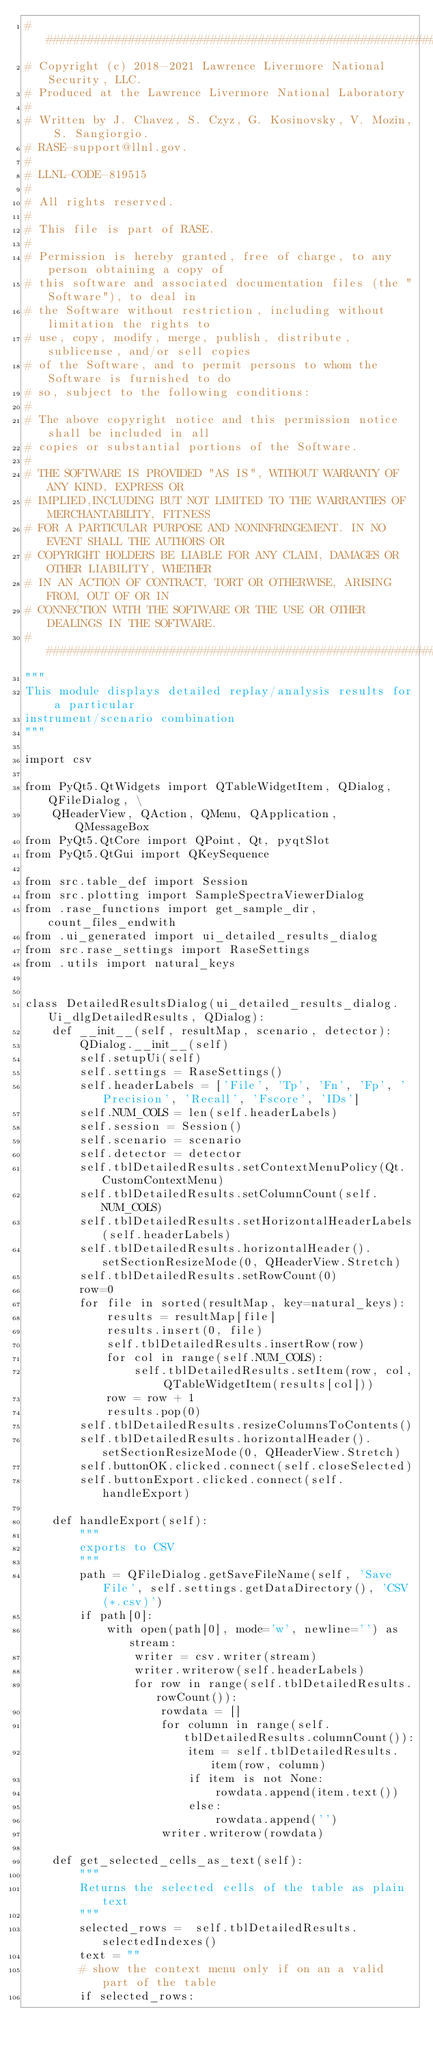Convert code to text. <code><loc_0><loc_0><loc_500><loc_500><_Python_>###############################################################################
# Copyright (c) 2018-2021 Lawrence Livermore National Security, LLC.
# Produced at the Lawrence Livermore National Laboratory
#
# Written by J. Chavez, S. Czyz, G. Kosinovsky, V. Mozin, S. Sangiorgio.
# RASE-support@llnl.gov.
#
# LLNL-CODE-819515
#
# All rights reserved.
#
# This file is part of RASE.
#
# Permission is hereby granted, free of charge, to any person obtaining a copy of
# this software and associated documentation files (the "Software"), to deal in
# the Software without restriction, including without limitation the rights to
# use, copy, modify, merge, publish, distribute, sublicense, and/or sell copies
# of the Software, and to permit persons to whom the Software is furnished to do
# so, subject to the following conditions:
#
# The above copyright notice and this permission notice shall be included in all
# copies or substantial portions of the Software.
#
# THE SOFTWARE IS PROVIDED "AS IS", WITHOUT WARRANTY OF ANY KIND, EXPRESS OR
# IMPLIED,INCLUDING BUT NOT LIMITED TO THE WARRANTIES OF MERCHANTABILITY, FITNESS
# FOR A PARTICULAR PURPOSE AND NONINFRINGEMENT. IN NO EVENT SHALL THE AUTHORS OR
# COPYRIGHT HOLDERS BE LIABLE FOR ANY CLAIM, DAMAGES OR OTHER LIABILITY, WHETHER
# IN AN ACTION OF CONTRACT, TORT OR OTHERWISE, ARISING FROM, OUT OF OR IN
# CONNECTION WITH THE SOFTWARE OR THE USE OR OTHER DEALINGS IN THE SOFTWARE.
###############################################################################
"""
This module displays detailed replay/analysis results for a particular
instrument/scenario combination
"""

import csv

from PyQt5.QtWidgets import QTableWidgetItem, QDialog, QFileDialog, \
    QHeaderView, QAction, QMenu, QApplication, QMessageBox
from PyQt5.QtCore import QPoint, Qt, pyqtSlot
from PyQt5.QtGui import QKeySequence

from src.table_def import Session
from src.plotting import SampleSpectraViewerDialog
from .rase_functions import get_sample_dir, count_files_endwith
from .ui_generated import ui_detailed_results_dialog
from src.rase_settings import RaseSettings
from .utils import natural_keys


class DetailedResultsDialog(ui_detailed_results_dialog.Ui_dlgDetailedResults, QDialog):
    def __init__(self, resultMap, scenario, detector):
        QDialog.__init__(self)
        self.setupUi(self)
        self.settings = RaseSettings()
        self.headerLabels = ['File', 'Tp', 'Fn', 'Fp', 'Precision', 'Recall', 'Fscore', 'IDs']
        self.NUM_COLS = len(self.headerLabels)
        self.session = Session()
        self.scenario = scenario
        self.detector = detector
        self.tblDetailedResults.setContextMenuPolicy(Qt.CustomContextMenu)
        self.tblDetailedResults.setColumnCount(self.NUM_COLS)
        self.tblDetailedResults.setHorizontalHeaderLabels(self.headerLabels)
        self.tblDetailedResults.horizontalHeader().setSectionResizeMode(0, QHeaderView.Stretch)
        self.tblDetailedResults.setRowCount(0)
        row=0
        for file in sorted(resultMap, key=natural_keys):
            results = resultMap[file]
            results.insert(0, file)
            self.tblDetailedResults.insertRow(row)
            for col in range(self.NUM_COLS):
                self.tblDetailedResults.setItem(row, col, QTableWidgetItem(results[col]))
            row = row + 1
            results.pop(0)
        self.tblDetailedResults.resizeColumnsToContents()
        self.tblDetailedResults.horizontalHeader().setSectionResizeMode(0, QHeaderView.Stretch)
        self.buttonOK.clicked.connect(self.closeSelected)
        self.buttonExport.clicked.connect(self.handleExport)

    def handleExport(self):
        """
        exports to CSV
        """
        path = QFileDialog.getSaveFileName(self, 'Save File', self.settings.getDataDirectory(), 'CSV (*.csv)')
        if path[0]:
            with open(path[0], mode='w', newline='') as stream:
                writer = csv.writer(stream)
                writer.writerow(self.headerLabels)
                for row in range(self.tblDetailedResults.rowCount()):
                    rowdata = []
                    for column in range(self.tblDetailedResults.columnCount()):
                        item = self.tblDetailedResults.item(row, column)
                        if item is not None:
                            rowdata.append(item.text())
                        else:
                            rowdata.append('')
                    writer.writerow(rowdata)

    def get_selected_cells_as_text(self):
        """
        Returns the selected cells of the table as plain text
        """
        selected_rows =  self.tblDetailedResults.selectedIndexes()
        text = ""
        # show the context menu only if on an a valid part of the table
        if selected_rows:</code> 